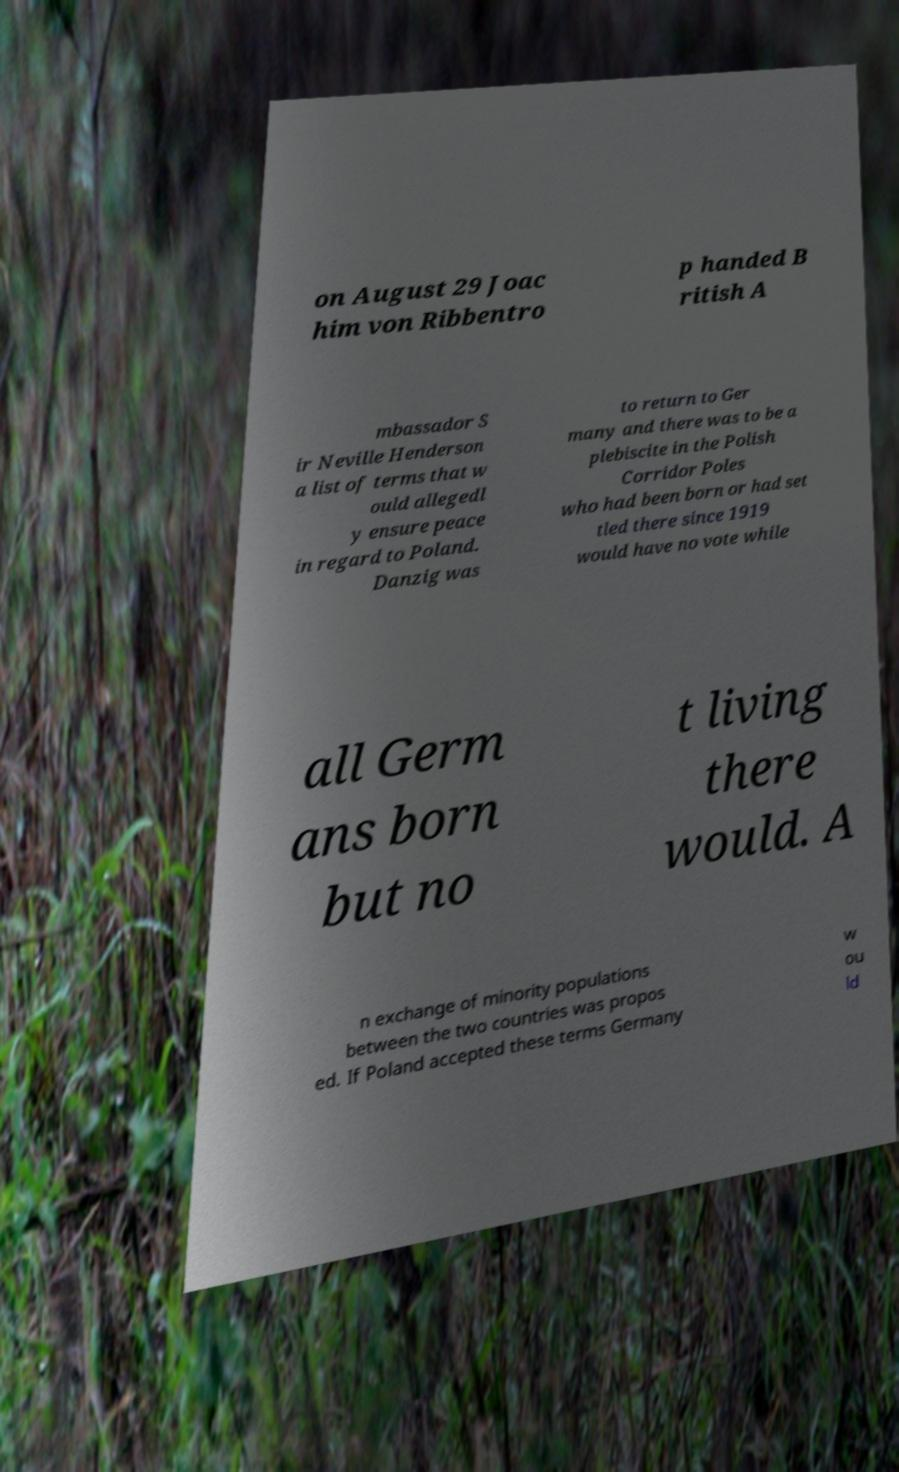For documentation purposes, I need the text within this image transcribed. Could you provide that? on August 29 Joac him von Ribbentro p handed B ritish A mbassador S ir Neville Henderson a list of terms that w ould allegedl y ensure peace in regard to Poland. Danzig was to return to Ger many and there was to be a plebiscite in the Polish Corridor Poles who had been born or had set tled there since 1919 would have no vote while all Germ ans born but no t living there would. A n exchange of minority populations between the two countries was propos ed. If Poland accepted these terms Germany w ou ld 